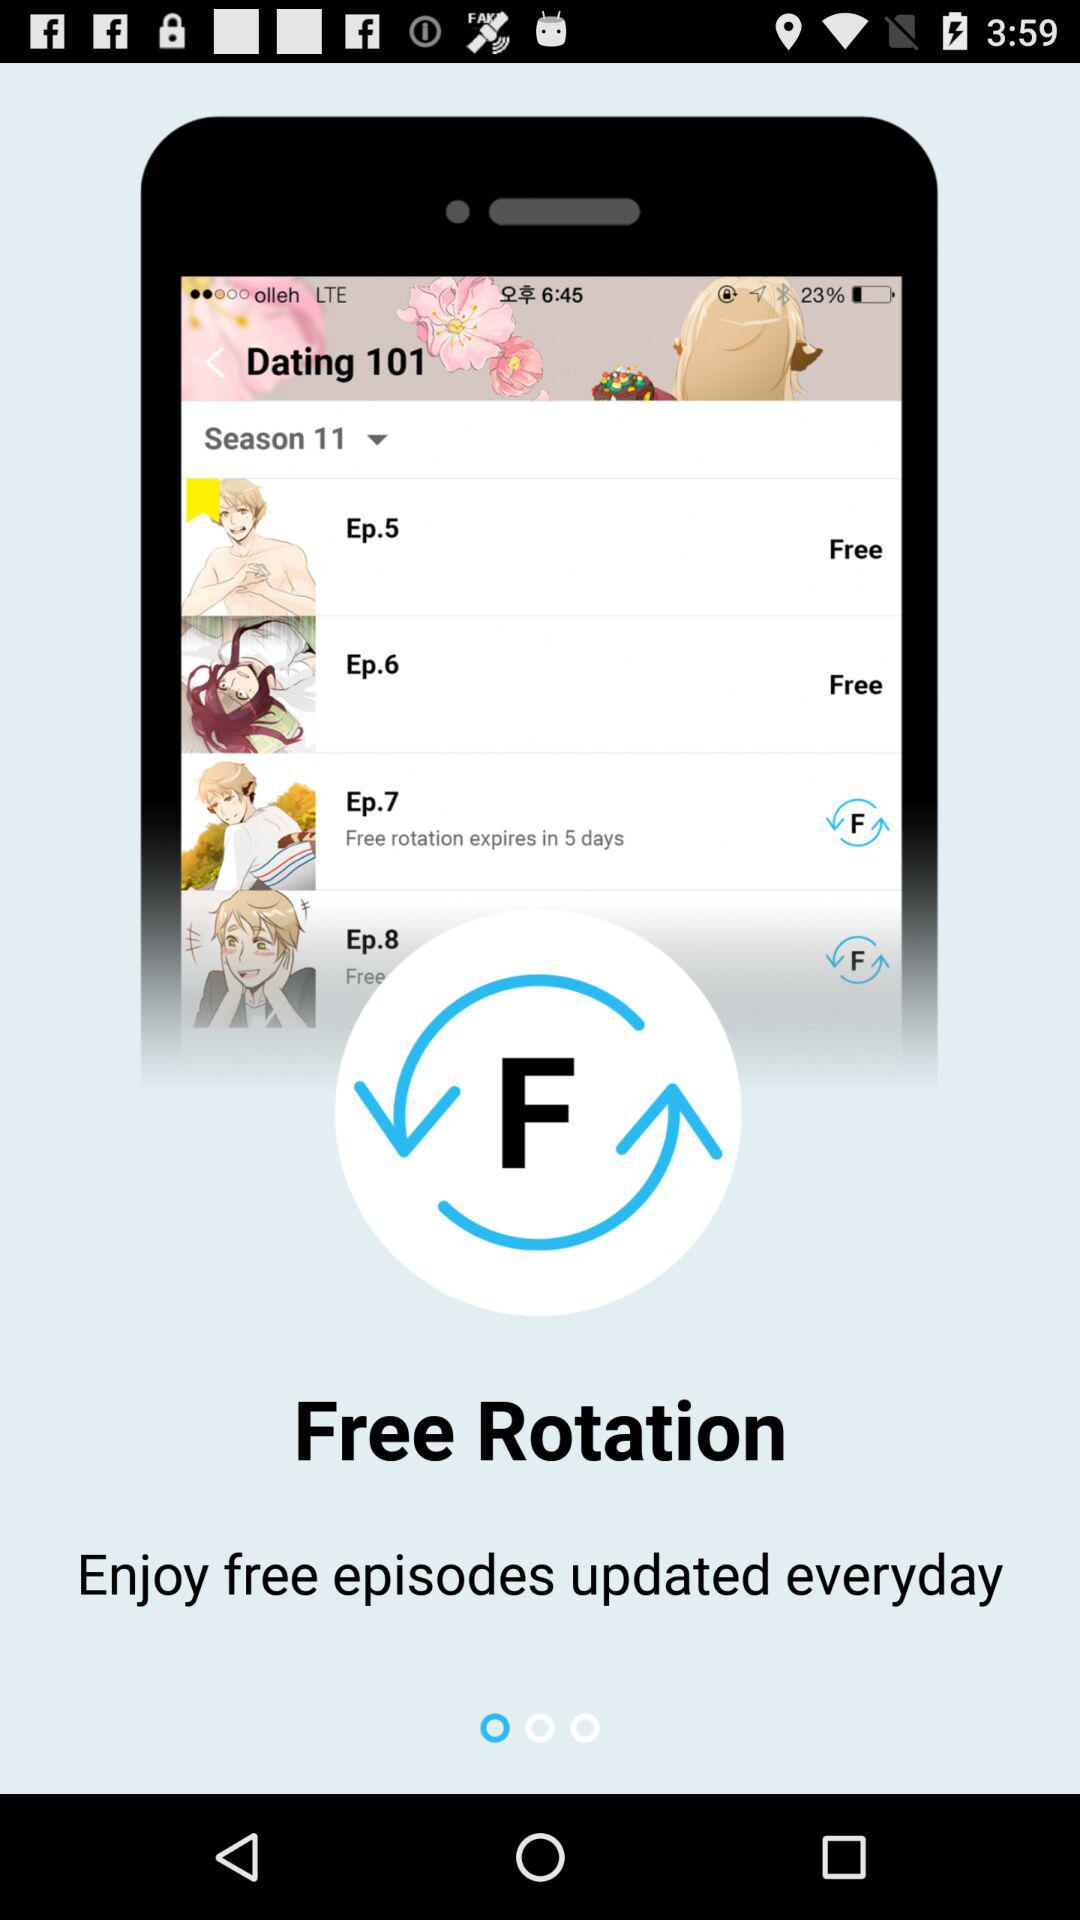Which season is this? This is season 11. 